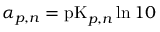<formula> <loc_0><loc_0><loc_500><loc_500>\alpha _ { p , n } = p K _ { p , n } \ln { 1 0 }</formula> 